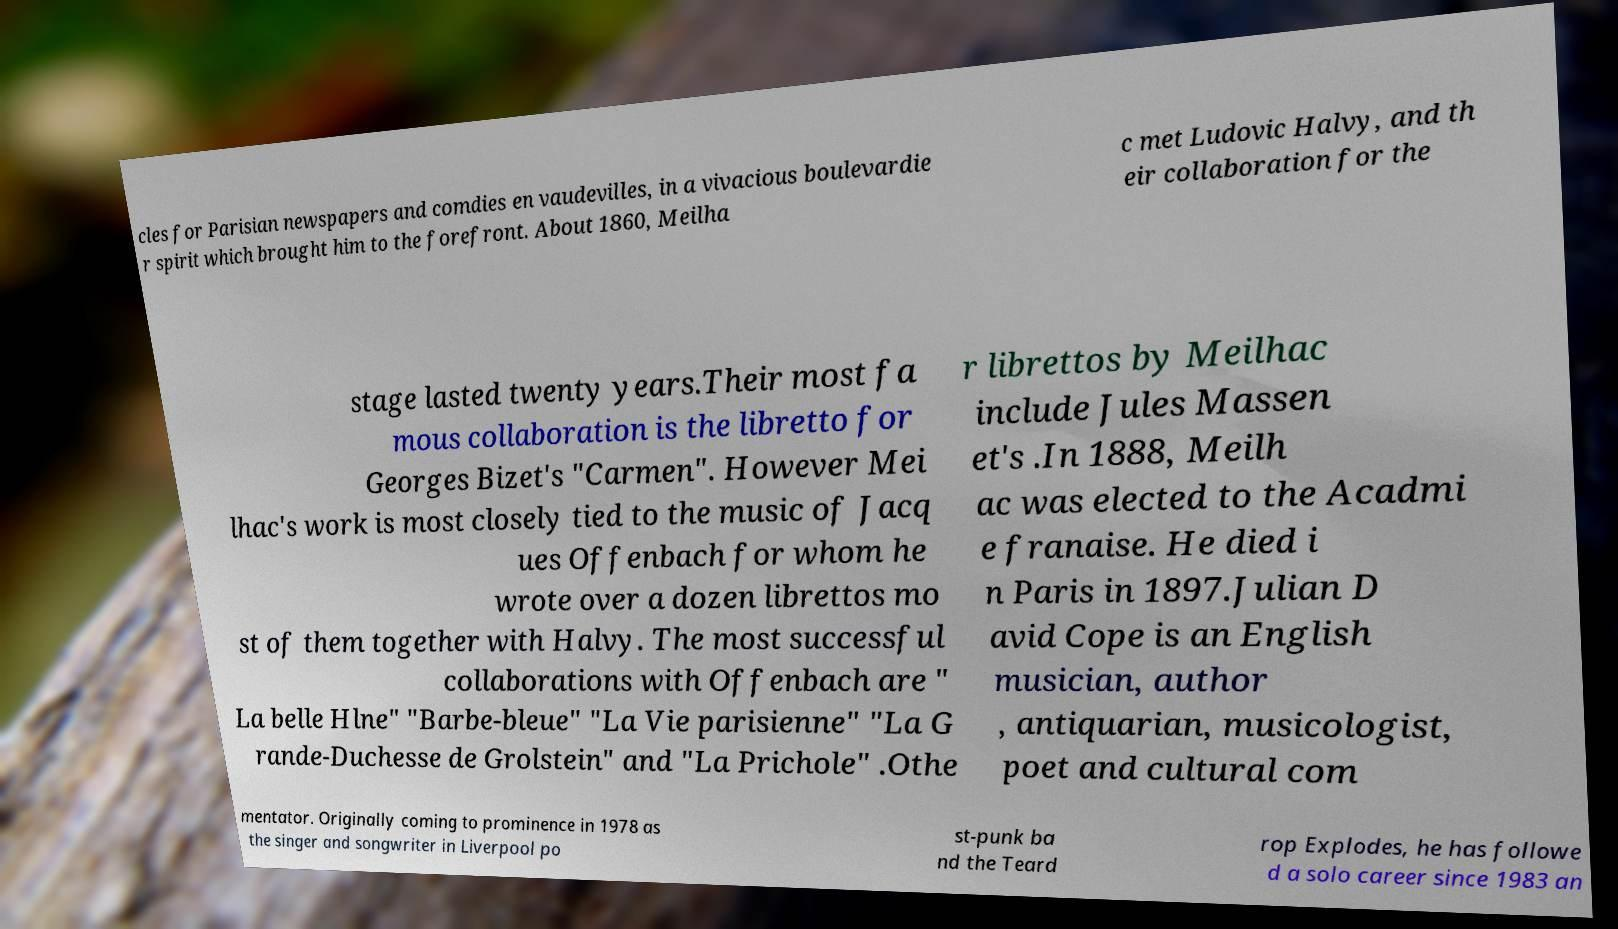I need the written content from this picture converted into text. Can you do that? cles for Parisian newspapers and comdies en vaudevilles, in a vivacious boulevardie r spirit which brought him to the forefront. About 1860, Meilha c met Ludovic Halvy, and th eir collaboration for the stage lasted twenty years.Their most fa mous collaboration is the libretto for Georges Bizet's "Carmen". However Mei lhac's work is most closely tied to the music of Jacq ues Offenbach for whom he wrote over a dozen librettos mo st of them together with Halvy. The most successful collaborations with Offenbach are " La belle Hlne" "Barbe-bleue" "La Vie parisienne" "La G rande-Duchesse de Grolstein" and "La Prichole" .Othe r librettos by Meilhac include Jules Massen et's .In 1888, Meilh ac was elected to the Acadmi e franaise. He died i n Paris in 1897.Julian D avid Cope is an English musician, author , antiquarian, musicologist, poet and cultural com mentator. Originally coming to prominence in 1978 as the singer and songwriter in Liverpool po st-punk ba nd the Teard rop Explodes, he has followe d a solo career since 1983 an 